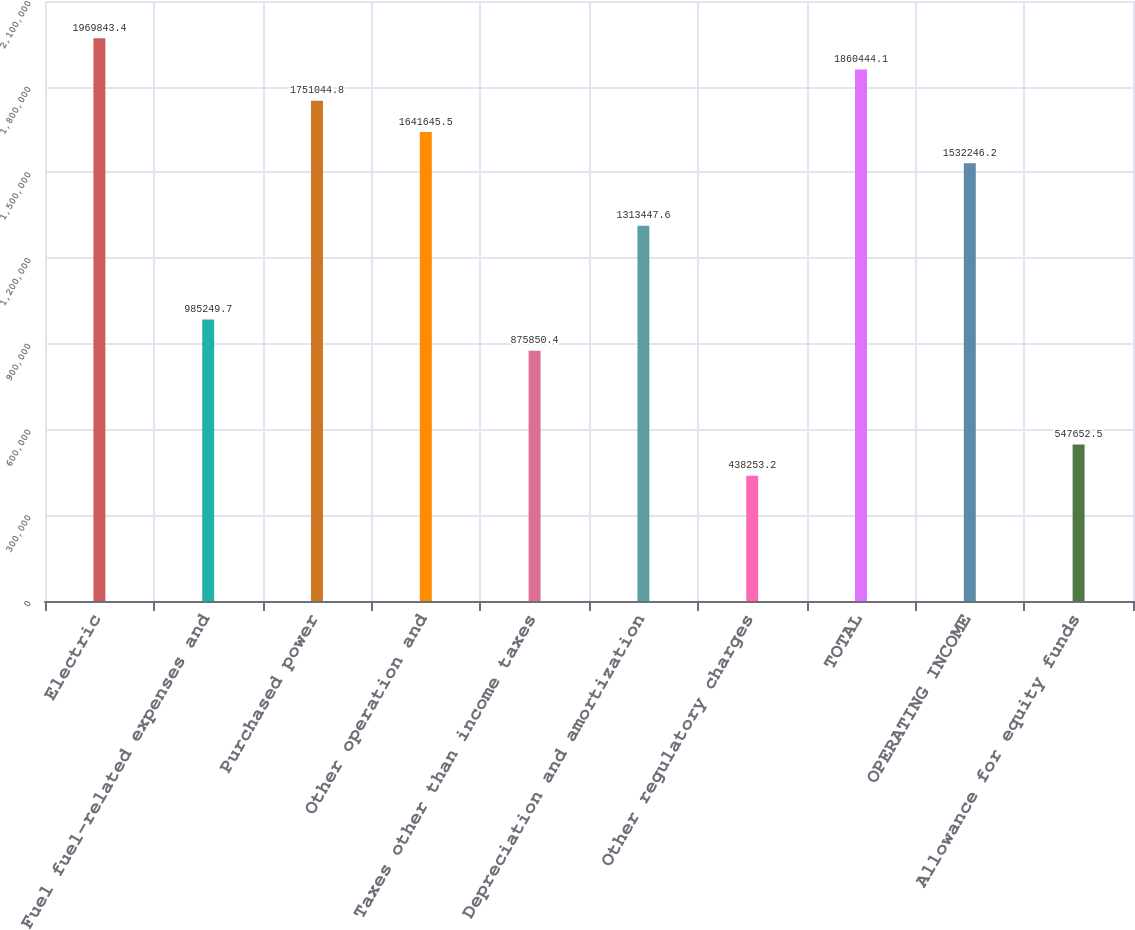<chart> <loc_0><loc_0><loc_500><loc_500><bar_chart><fcel>Electric<fcel>Fuel fuel-related expenses and<fcel>Purchased power<fcel>Other operation and<fcel>Taxes other than income taxes<fcel>Depreciation and amortization<fcel>Other regulatory charges<fcel>TOTAL<fcel>OPERATING INCOME<fcel>Allowance for equity funds<nl><fcel>1.96984e+06<fcel>985250<fcel>1.75104e+06<fcel>1.64165e+06<fcel>875850<fcel>1.31345e+06<fcel>438253<fcel>1.86044e+06<fcel>1.53225e+06<fcel>547652<nl></chart> 